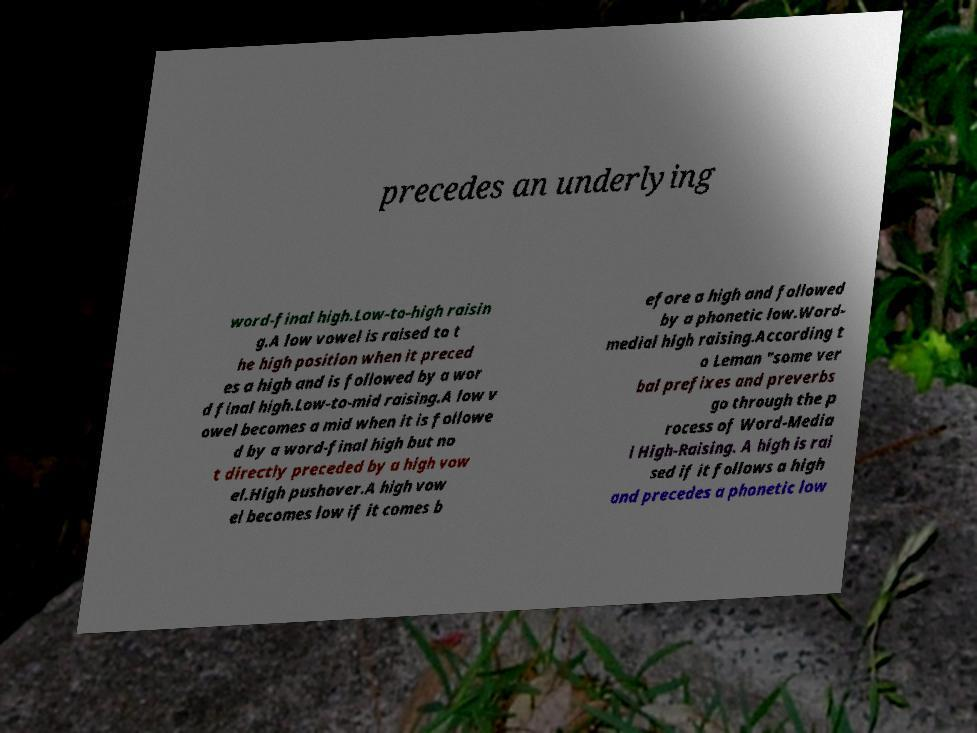I need the written content from this picture converted into text. Can you do that? precedes an underlying word-final high.Low-to-high raisin g.A low vowel is raised to t he high position when it preced es a high and is followed by a wor d final high.Low-to-mid raising.A low v owel becomes a mid when it is followe d by a word-final high but no t directly preceded by a high vow el.High pushover.A high vow el becomes low if it comes b efore a high and followed by a phonetic low.Word- medial high raising.According t o Leman "some ver bal prefixes and preverbs go through the p rocess of Word-Media l High-Raising. A high is rai sed if it follows a high and precedes a phonetic low 